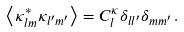<formula> <loc_0><loc_0><loc_500><loc_500>\left < \kappa _ { l m } ^ { * } \kappa _ { l ^ { \prime } m ^ { \prime } } \right > = C _ { l } ^ { \kappa } \delta _ { l l ^ { \prime } } \delta _ { m m ^ { \prime } } \, .</formula> 